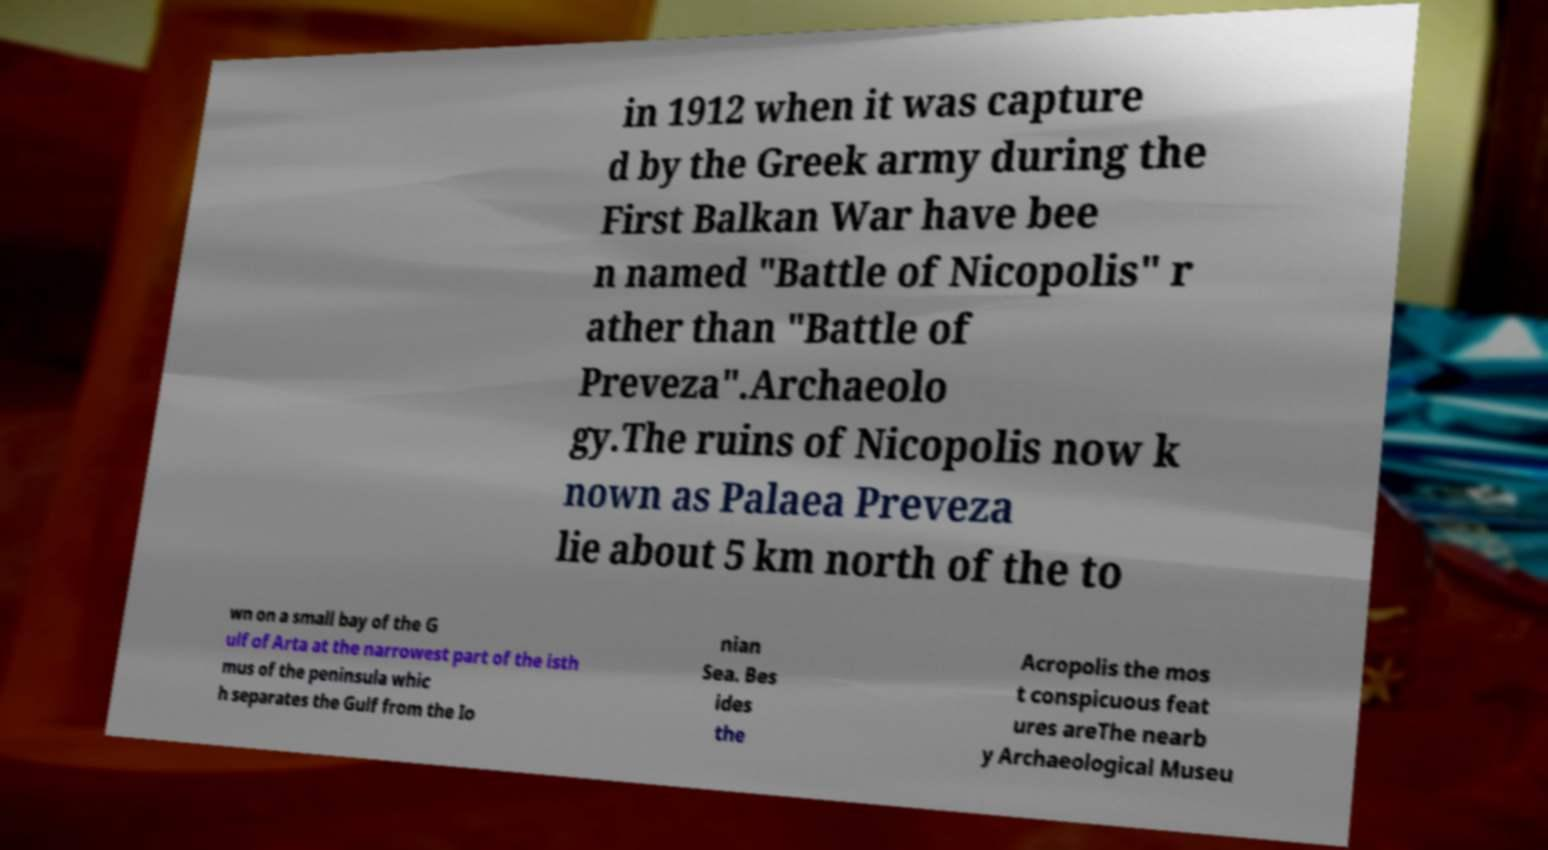I need the written content from this picture converted into text. Can you do that? in 1912 when it was capture d by the Greek army during the First Balkan War have bee n named "Battle of Nicopolis" r ather than "Battle of Preveza".Archaeolo gy.The ruins of Nicopolis now k nown as Palaea Preveza lie about 5 km north of the to wn on a small bay of the G ulf of Arta at the narrowest part of the isth mus of the peninsula whic h separates the Gulf from the Io nian Sea. Bes ides the Acropolis the mos t conspicuous feat ures areThe nearb y Archaeological Museu 